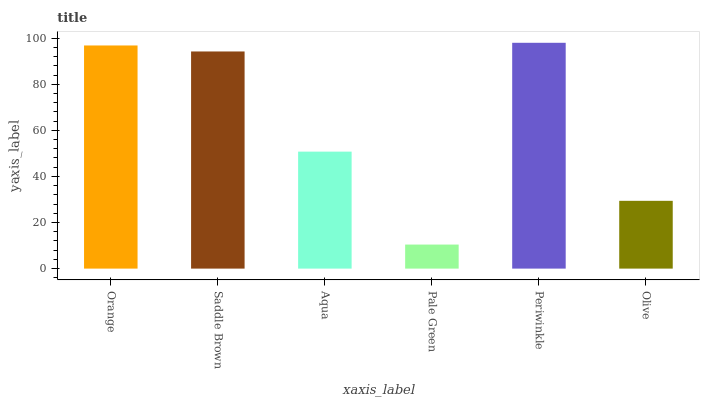Is Pale Green the minimum?
Answer yes or no. Yes. Is Periwinkle the maximum?
Answer yes or no. Yes. Is Saddle Brown the minimum?
Answer yes or no. No. Is Saddle Brown the maximum?
Answer yes or no. No. Is Orange greater than Saddle Brown?
Answer yes or no. Yes. Is Saddle Brown less than Orange?
Answer yes or no. Yes. Is Saddle Brown greater than Orange?
Answer yes or no. No. Is Orange less than Saddle Brown?
Answer yes or no. No. Is Saddle Brown the high median?
Answer yes or no. Yes. Is Aqua the low median?
Answer yes or no. Yes. Is Periwinkle the high median?
Answer yes or no. No. Is Periwinkle the low median?
Answer yes or no. No. 